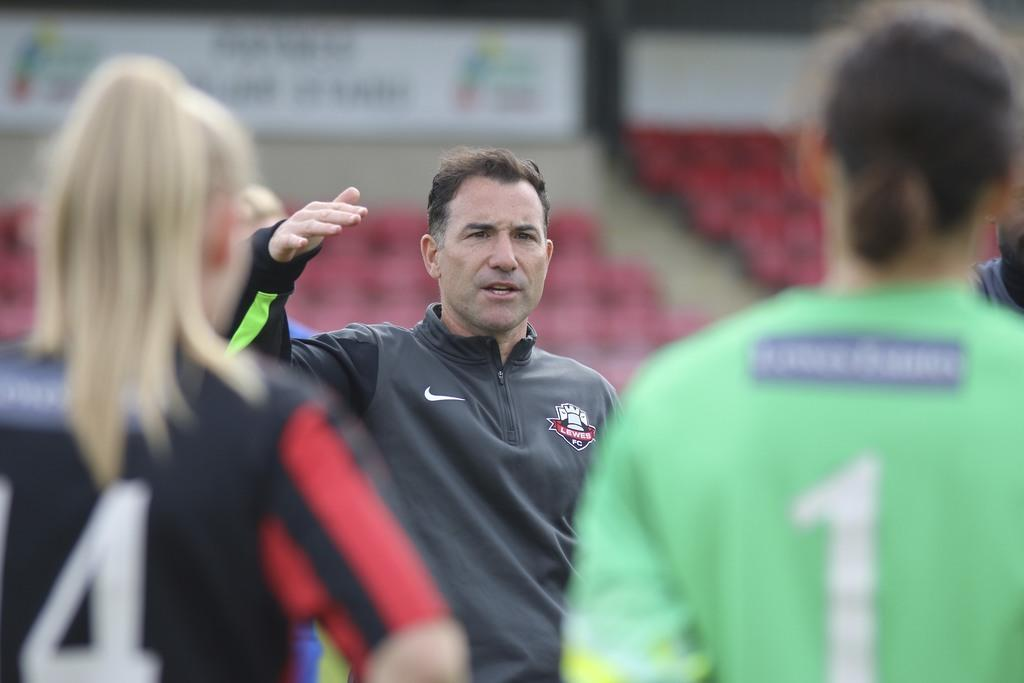Who or what can be seen in the image? There are people in the image. What objects are visible in the background? There are chairs in the background of the image. Are there any additional elements in the image? Yes, there are banners in the image. What is the income of the kitten in the image? There is no kitten present in the image, so it is not possible to determine its income. 